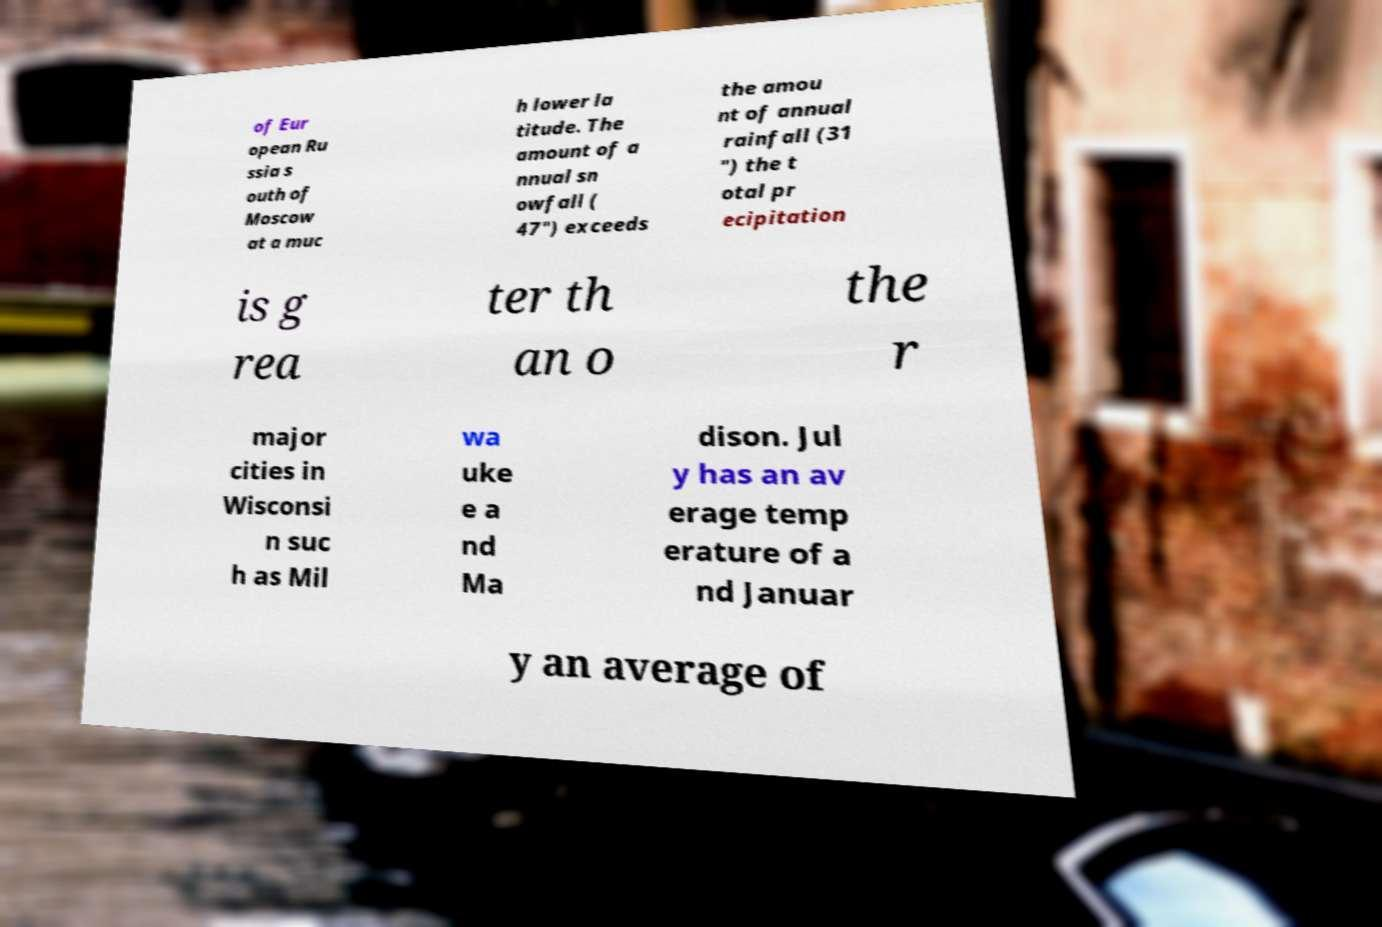Can you accurately transcribe the text from the provided image for me? of Eur opean Ru ssia s outh of Moscow at a muc h lower la titude. The amount of a nnual sn owfall ( 47") exceeds the amou nt of annual rainfall (31 ") the t otal pr ecipitation is g rea ter th an o the r major cities in Wisconsi n suc h as Mil wa uke e a nd Ma dison. Jul y has an av erage temp erature of a nd Januar y an average of 